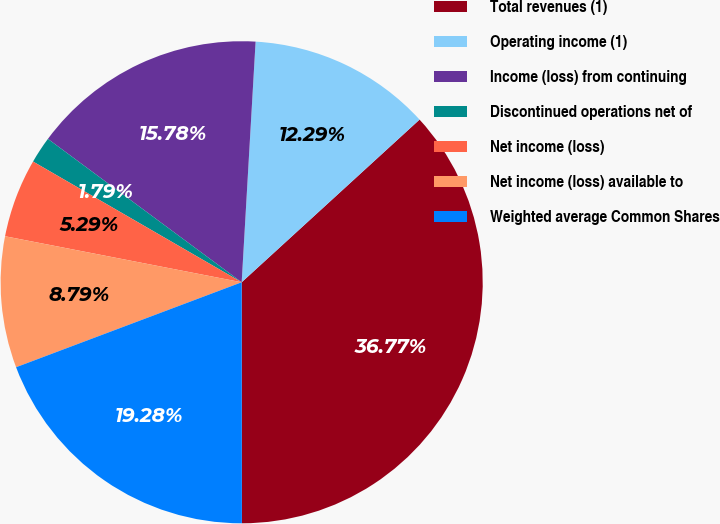Convert chart to OTSL. <chart><loc_0><loc_0><loc_500><loc_500><pie_chart><fcel>Total revenues (1)<fcel>Operating income (1)<fcel>Income (loss) from continuing<fcel>Discontinued operations net of<fcel>Net income (loss)<fcel>Net income (loss) available to<fcel>Weighted average Common Shares<nl><fcel>36.77%<fcel>12.29%<fcel>15.78%<fcel>1.79%<fcel>5.29%<fcel>8.79%<fcel>19.28%<nl></chart> 